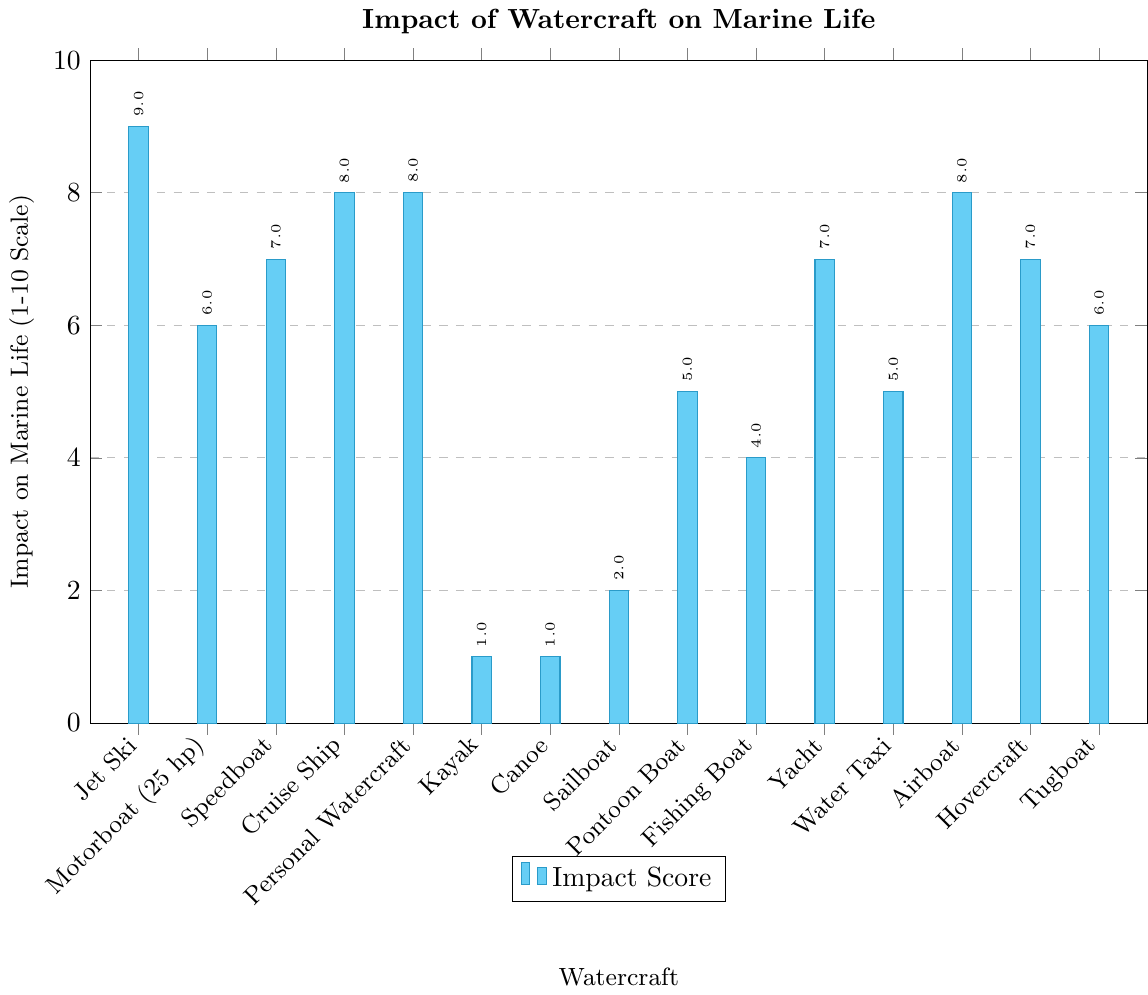Which watercraft has the highest impact on marine life according to the chart? The chart shows the impact on marine life on a scale of 1 to 10. The Jet Ski has an impact score of 9, which is the highest among all watercraft listed.
Answer: Jet Ski Which watercraft have an impact score of 8 on marine life? By examining the y-axis values, we can identify that Cruise Ship, Personal Watercraft, and Airboat each have an impact score of 8 on marine life.
Answer: Cruise Ship, Personal Watercraft, Airboat How does the impact score of Jet Ski compare to that of a Kayak? The chart shows that the Jet Ski has an impact score of 9, whereas the Kayak has an impact score of 1. This means the Jet Ski has a significantly higher impact on marine life compared to the Kayak.
Answer: Jet Ski has a higher impact What is the combined impact score of non-motorized watercraft (Kayak, Canoe, Sailboat)? From the chart, the impact scores of Kayak, Canoe, and Sailboat are 1, 1, and 2, respectively. By adding these scores, 1 + 1 + 2 = 4.
Answer: 4 Which watercraft have an impact score less than 5 on marine life? By looking at the y-axis and values next to the bars, Kayak, Canoe, Sailboat, Fishing Boat, and Water Taxi each have impact scores less than 5.
Answer: Kayak, Canoe, Sailboat, Fishing Boat, Water Taxi What is the average impact score of all watercraft? Add up all the impact scores from the bars in the chart. The total is 9 (Jet Ski) + 6 (Motorboat) + 7 (Speedboat) + 8 (Cruise Ship) + 8 (Personal Watercraft) + 1 (Kayak) + 1 (Canoe) + 2 (Sailboat) + 5 (Pontoon Boat) + 4 (Fishing Boat) + 7 (Yacht) + 5 (Water Taxi) + 8 (Airboat) + 7 (Hovercraft) + 6 (Tugboat) = 84. There are 15 types of watercraft, so the average is 84 / 15 = 5.6.
Answer: 5.6 How much higher is the impact score of a Jet Ski compared to a Fishing Boat? Jet Ski has an impact score of 9, and Fishing Boat has an impact score of 4. The difference is 9 - 4 = 5.
Answer: 5 Among the motorized watercraft, which one has the lowest impact score and what is it? Among the motorized watercraft (excluding Kayak, Canoe, and Sailboat), the Fishing Boat has the lowest impact score, which is 4.
Answer: Fishing Boat, 4 Which watercraft have the same impact score, and what is that score? The chart shows that Cruise Ship, Personal Watercraft, and Airboat all have an impact score of 8. Additionally, Speedboat, Yacht, and Hovercraft have a score of 7. Motorboat (25 hp) and Tugboat both have a score of 6, while Kayak and Canoe have a score of 1.
Answer: Cruise Ship, Personal Watercraft, Airboat (8); Speedboat, Yacht, Hovercraft (7); Motorboat (25 hp), Tugboat (6); Kayak, Canoe (1) How does the impact score of the Pontoon Boat compare to that of the Water Taxi? Both the Pontoon Boat and Water Taxi have an impact score of 5. Thus, their impact on marine life is the same.
Answer: They are the same 